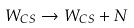<formula> <loc_0><loc_0><loc_500><loc_500>W _ { C S } \rightarrow W _ { C S } + N</formula> 